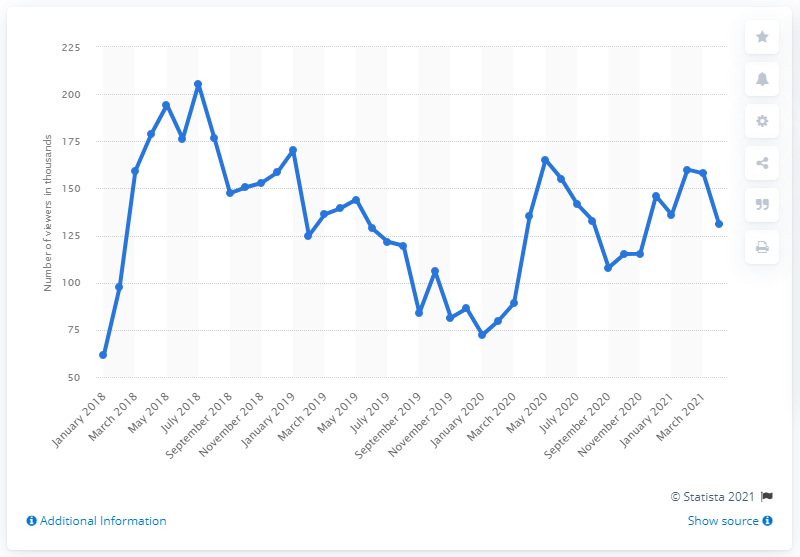List a handful of essential elements in this visual. According to data from April 2021, Fortnite events on Twitch were watched by an average of 131 thousand people. 